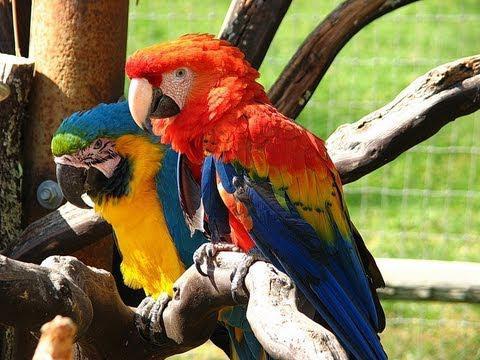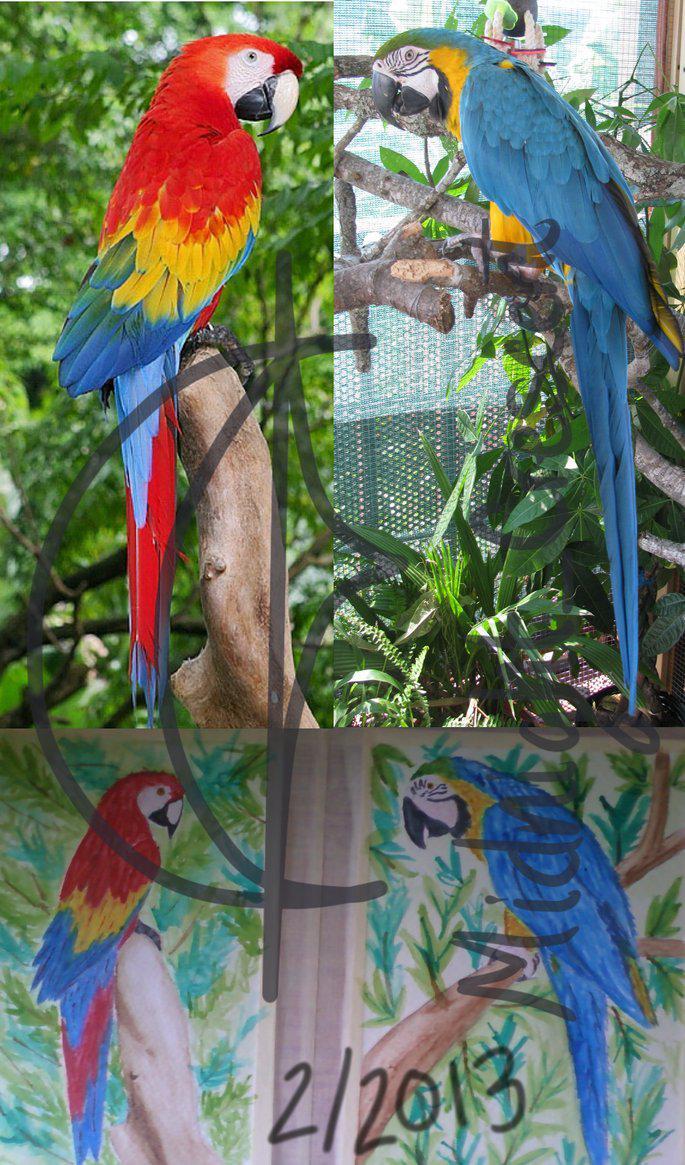The first image is the image on the left, the second image is the image on the right. For the images shown, is this caption "The left image contains exactly two parrots." true? Answer yes or no. Yes. The first image is the image on the left, the second image is the image on the right. Considering the images on both sides, is "There are a large number of parrots perched on a rocky wall." valid? Answer yes or no. No. 